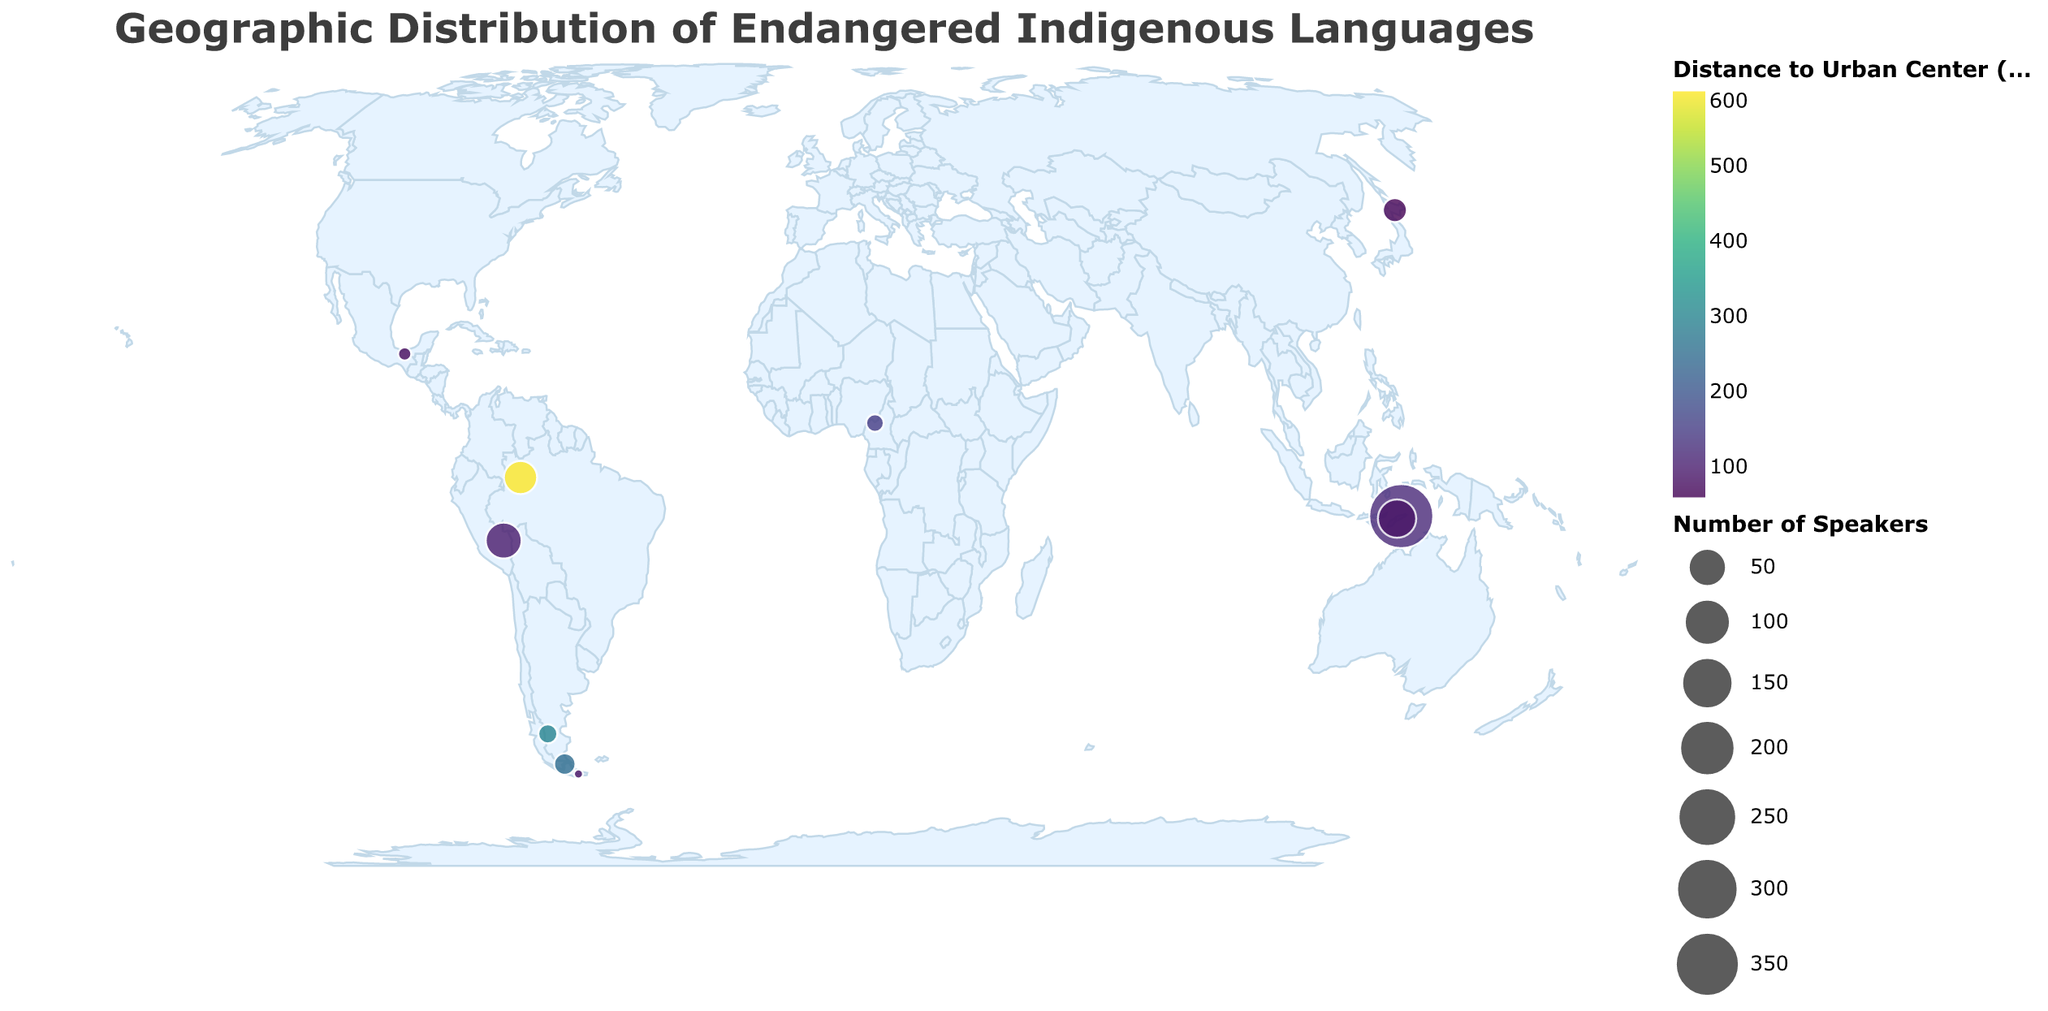What is the title of this figure? The title of a figure typically appears at the top and describes the main topic or content of the figure. In this case, it clearly states "Geographic Distribution of Endangered Indigenous Languages".
Answer: Geographic Distribution of Endangered Indigenous Languages Which language has the greatest number of speakers? To find this, look at the size of the circles in the plot, as they represent the number of speakers. The largest circle corresponds to Waima'a. Checking the data confirms that it has 350 speakers, the highest number among the listed languages.
Answer: Waima'a Which urban center is closest to its associated endangered language? To determine this, find the smallest value in the color scale representing distance. The smallest value is for Ainu, with a distance to Sapporo of 60 km.
Answer: Sapporo What is the distance between Kaixana and its nearest urban center, and how does it compare to that of Tehuelche? Kaixana is 600 km away from Manaus, while Tehuelche is 300 km away from Comodoro Rivadavia. Comparing these two distances, Kaixana is farther from its urban center by 300 km.
Answer: 600 km; Kaixana is farther by 300 km Which language is spoken furthest from its associated urban center? To identify this, find the circle with the darkest color in the gradient, which indicates a larger distance. Kaixana, indicated with a distance of 600 km to Manaus, is the furthest.
Answer: Kaixana What are the coordinates of the Yaghan language, and which urban center is it nearest to? Locate Yaghan on the map or its corresponding data. The coordinates are (-54.9333, -67.6167) and it is nearest to Ushuaia, 80 km away.
Answer: Coordinates: (-54.9333, -67.6167); Nearest urban center: Ushuaia Which language has the fewest speakers, and how far is it from the nearest urban center? The smallest circle will represent the language with the fewest speakers. Yaghan has the fewest, with only 1 speaker. It is 80 km away from Ushuaia.
Answer: Yaghan (1 speaker); 80 km How does the proximity of Waima'a to its urban center compare to Huachipaeri? Waima'a is 120 km away from Dili, while Huachipaeri is 95 km away from Puerto Maldonado. Thus, Huachipaeri is closer to its urban center by 25 km.
Answer: Huachipaeri is closer by 25 km What is the average number of speakers for the listed languages? To find the average, sum the number of speakers for each language and divide by the total number of languages: (2 + 1 + 4 + 40 + 30 + 350 + 50 + 10 + 5 + 7) / 10 = 499 / 10. The average number of speakers is approximately 49.9.
Answer: 49.9 Which two languages have the largest difference in the number of speakers? The largest difference can be found by subtracting the smallest number of speakers from the largest. The smallest number of speakers is 1 (Yaghan), and the largest is 350 (Waima'a). The difference is 350 - 1 = 349.
Answer: Yaghan and Waima'a; difference of 349 